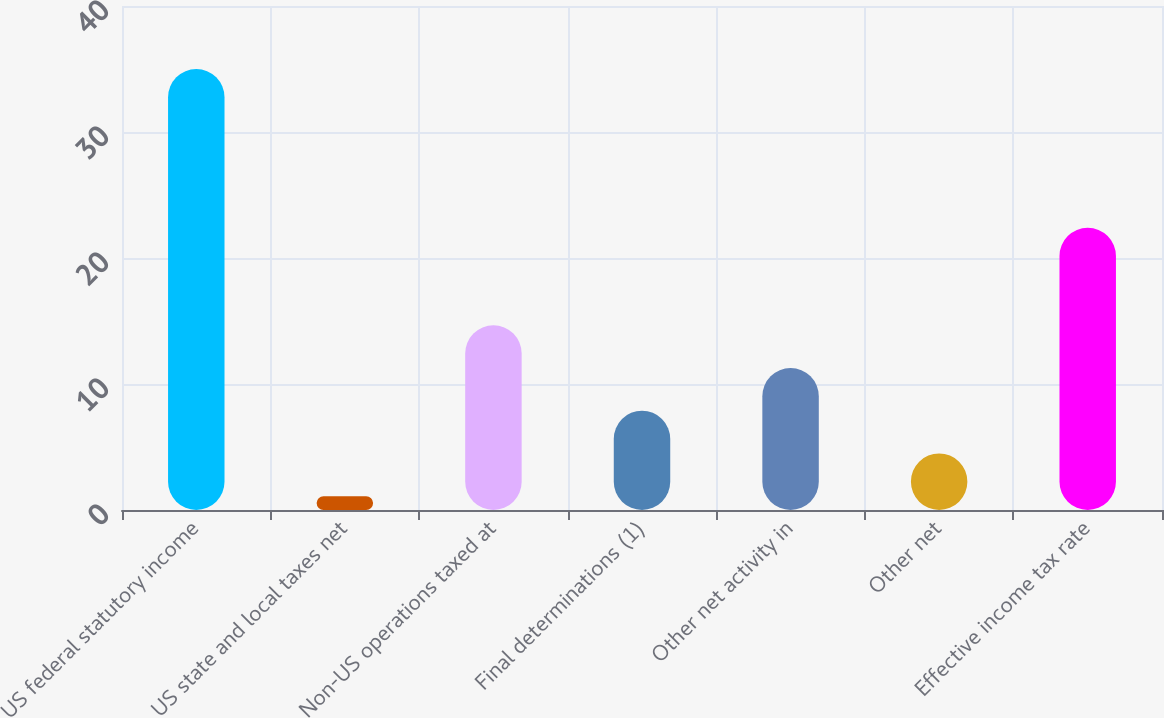Convert chart to OTSL. <chart><loc_0><loc_0><loc_500><loc_500><bar_chart><fcel>US federal statutory income<fcel>US state and local taxes net<fcel>Non-US operations taxed at<fcel>Final determinations (1)<fcel>Other net activity in<fcel>Other net<fcel>Effective income tax rate<nl><fcel>35<fcel>1.1<fcel>14.66<fcel>7.88<fcel>11.27<fcel>4.49<fcel>22.4<nl></chart> 